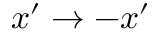Convert formula to latex. <formula><loc_0><loc_0><loc_500><loc_500>x ^ { \prime } \rightarrow - x ^ { \prime }</formula> 